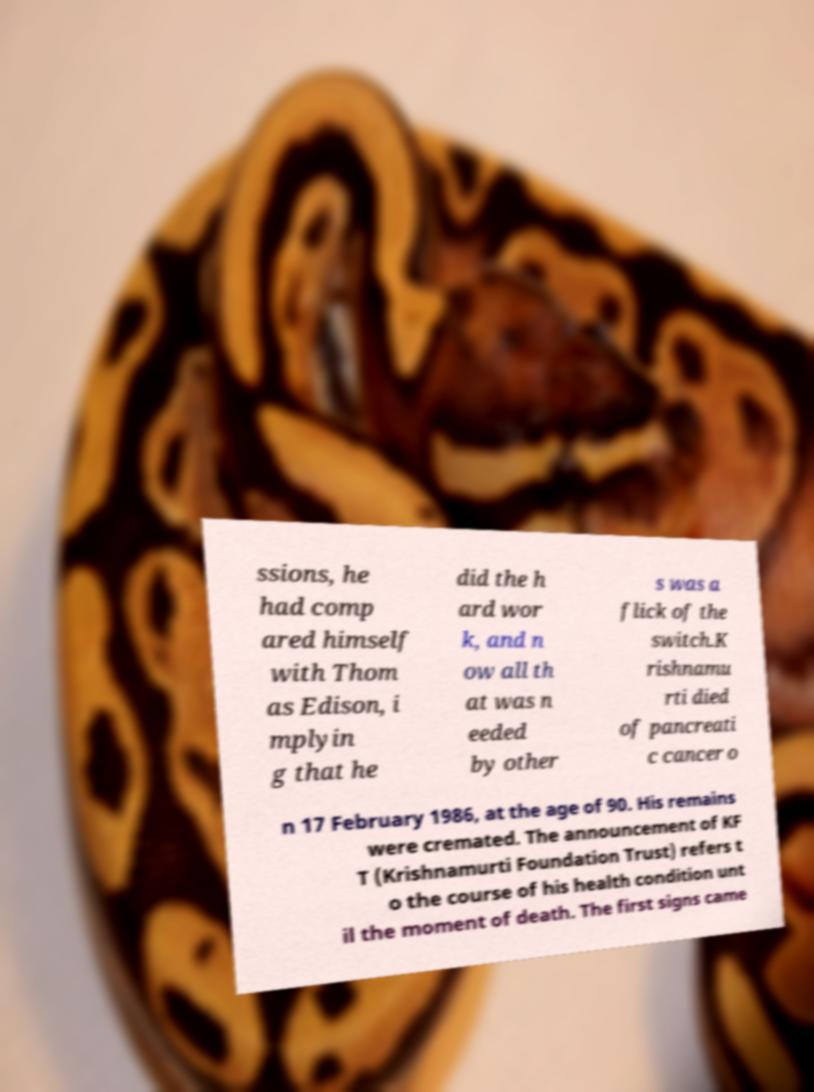Can you read and provide the text displayed in the image?This photo seems to have some interesting text. Can you extract and type it out for me? ssions, he had comp ared himself with Thom as Edison, i mplyin g that he did the h ard wor k, and n ow all th at was n eeded by other s was a flick of the switch.K rishnamu rti died of pancreati c cancer o n 17 February 1986, at the age of 90. His remains were cremated. The announcement of KF T (Krishnamurti Foundation Trust) refers t o the course of his health condition unt il the moment of death. The first signs came 